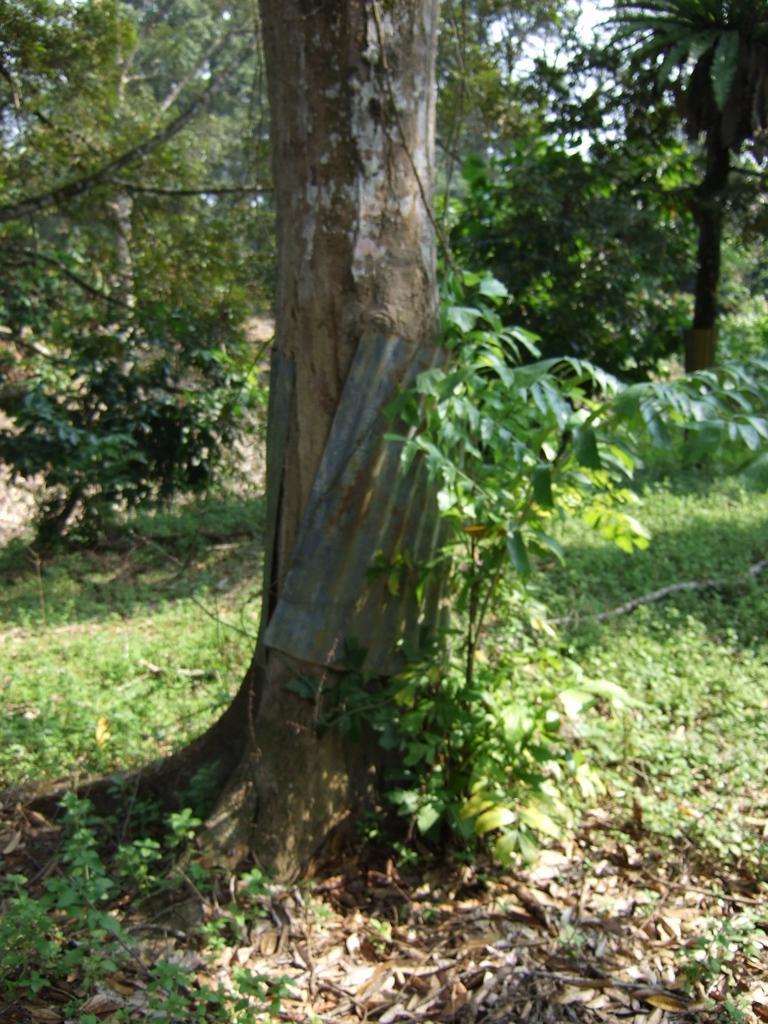In one or two sentences, can you explain what this image depicts? In the foreground of this image, there are plants on the ground and a tree trunk in the middle and there is a metal sheet around it. In the background, there are trees and the sky. 